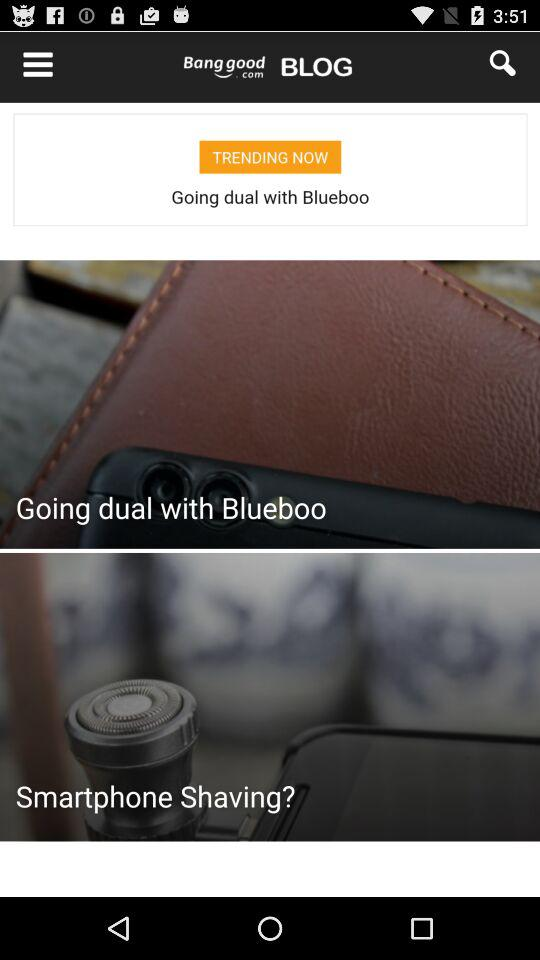How many products are in the cart? There is 1 product in the cart. 